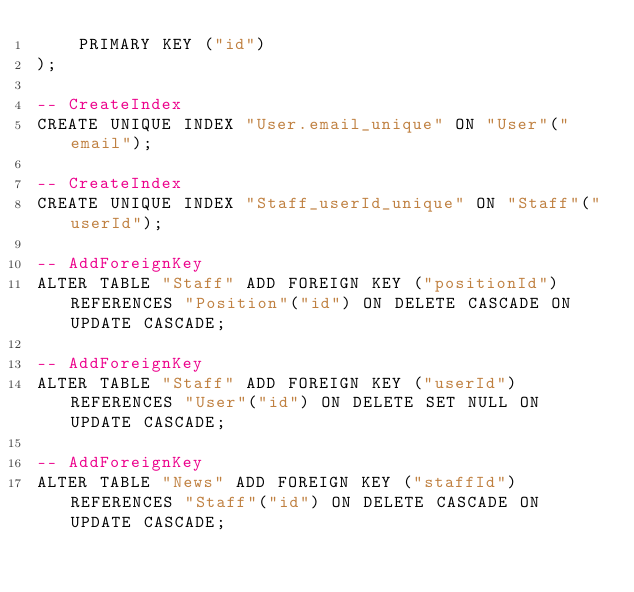Convert code to text. <code><loc_0><loc_0><loc_500><loc_500><_SQL_>    PRIMARY KEY ("id")
);

-- CreateIndex
CREATE UNIQUE INDEX "User.email_unique" ON "User"("email");

-- CreateIndex
CREATE UNIQUE INDEX "Staff_userId_unique" ON "Staff"("userId");

-- AddForeignKey
ALTER TABLE "Staff" ADD FOREIGN KEY ("positionId") REFERENCES "Position"("id") ON DELETE CASCADE ON UPDATE CASCADE;

-- AddForeignKey
ALTER TABLE "Staff" ADD FOREIGN KEY ("userId") REFERENCES "User"("id") ON DELETE SET NULL ON UPDATE CASCADE;

-- AddForeignKey
ALTER TABLE "News" ADD FOREIGN KEY ("staffId") REFERENCES "Staff"("id") ON DELETE CASCADE ON UPDATE CASCADE;
</code> 